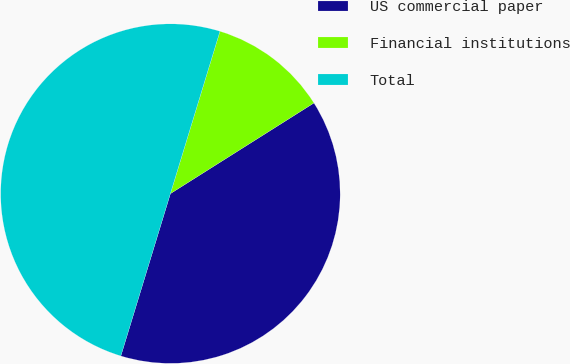Convert chart. <chart><loc_0><loc_0><loc_500><loc_500><pie_chart><fcel>US commercial paper<fcel>Financial institutions<fcel>Total<nl><fcel>38.68%<fcel>11.32%<fcel>50.0%<nl></chart> 